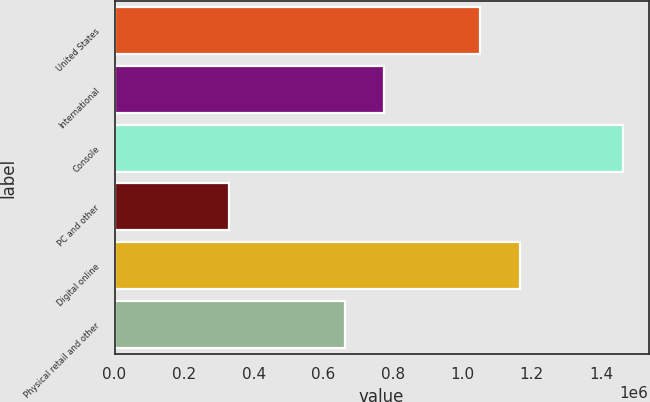Convert chart to OTSL. <chart><loc_0><loc_0><loc_500><loc_500><bar_chart><fcel>United States<fcel>International<fcel>Console<fcel>PC and other<fcel>Digital online<fcel>Physical retail and other<nl><fcel>1.05231e+06<fcel>775318<fcel>1.46331e+06<fcel>329586<fcel>1.16568e+06<fcel>661946<nl></chart> 